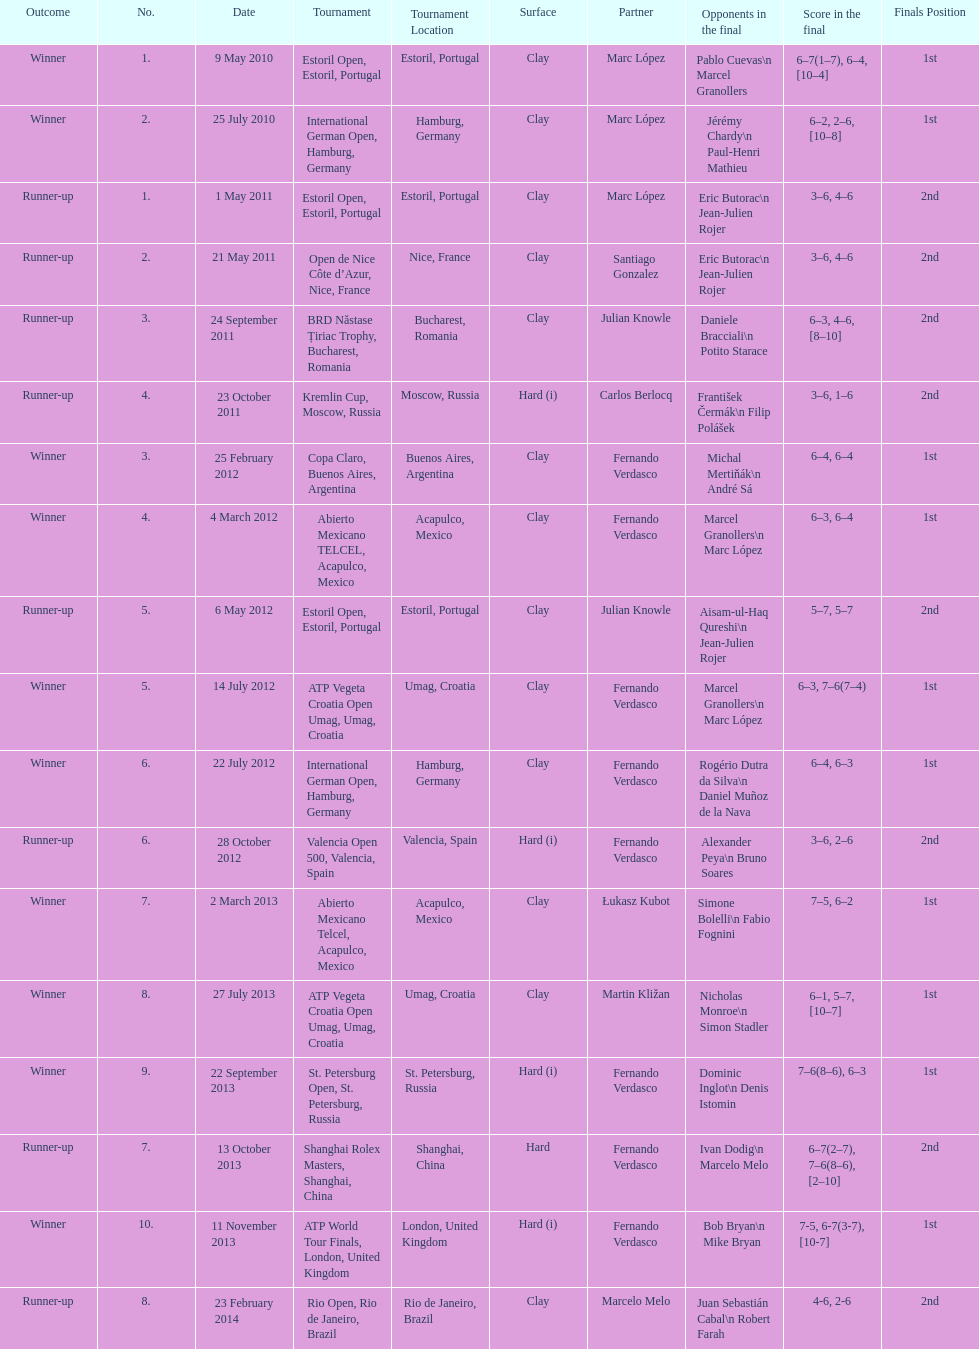What tournament was before the estoril open? Abierto Mexicano TELCEL, Acapulco, Mexico. 